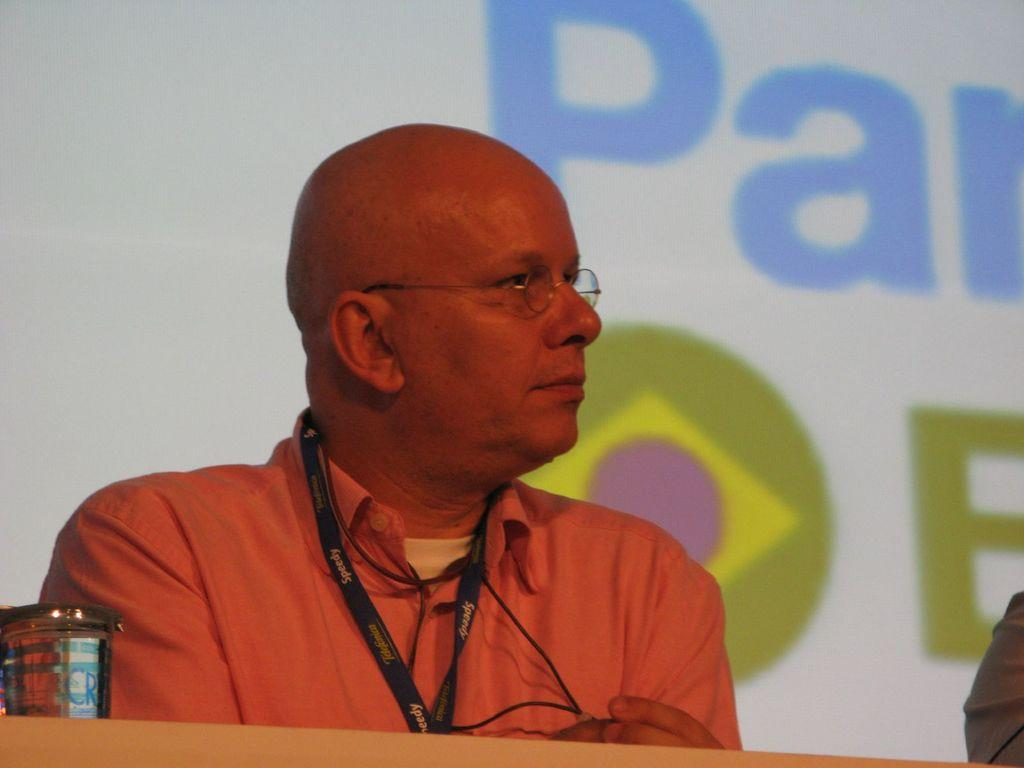Who is the main subject in the image? There is a person in the center of the image. What is the person wearing that provides identification? The person is wearing an ID card. What can be seen in the background of the image? There is a banner with text in the background of the image. What is located on the left side of the image? There is a glass on the left side of the image. How many men are pointing their feet in the image? There is no mention of men or feet in the image, so it is impossible to answer this question. 